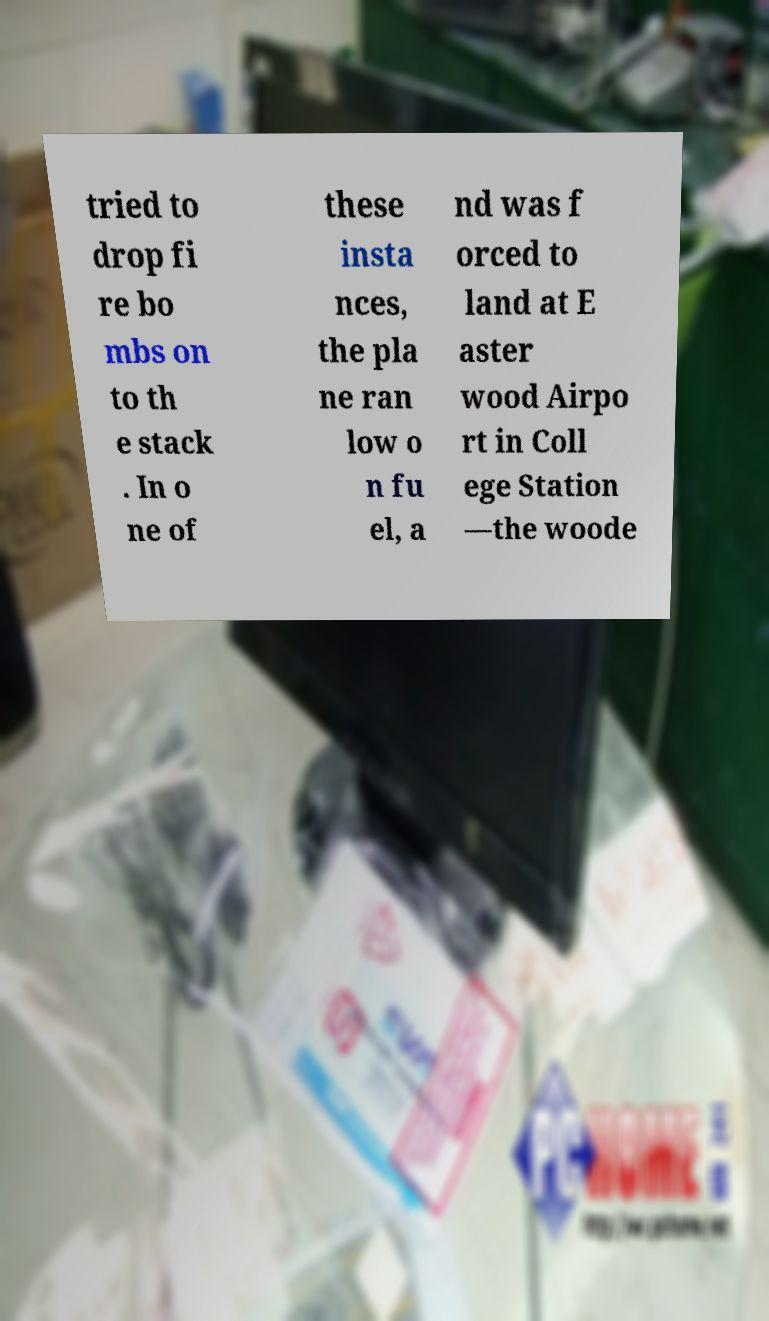Can you read and provide the text displayed in the image?This photo seems to have some interesting text. Can you extract and type it out for me? tried to drop fi re bo mbs on to th e stack . In o ne of these insta nces, the pla ne ran low o n fu el, a nd was f orced to land at E aster wood Airpo rt in Coll ege Station —the woode 